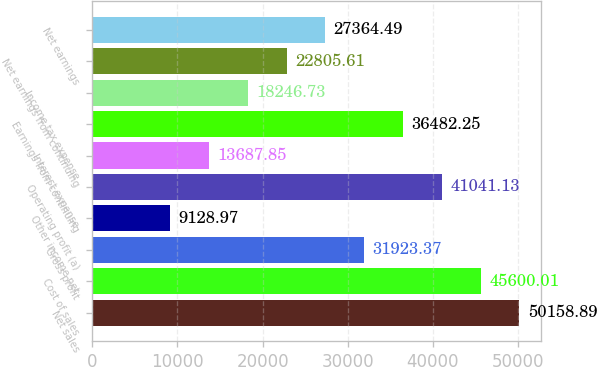Convert chart. <chart><loc_0><loc_0><loc_500><loc_500><bar_chart><fcel>Net sales<fcel>Cost of sales<fcel>Gross profit<fcel>Other income net<fcel>Operating profit (a)<fcel>Interest expense<fcel>Earnings from continuing<fcel>Income tax expense<fcel>Net earnings from continuing<fcel>Net earnings<nl><fcel>50158.9<fcel>45600<fcel>31923.4<fcel>9128.97<fcel>41041.1<fcel>13687.9<fcel>36482.2<fcel>18246.7<fcel>22805.6<fcel>27364.5<nl></chart> 